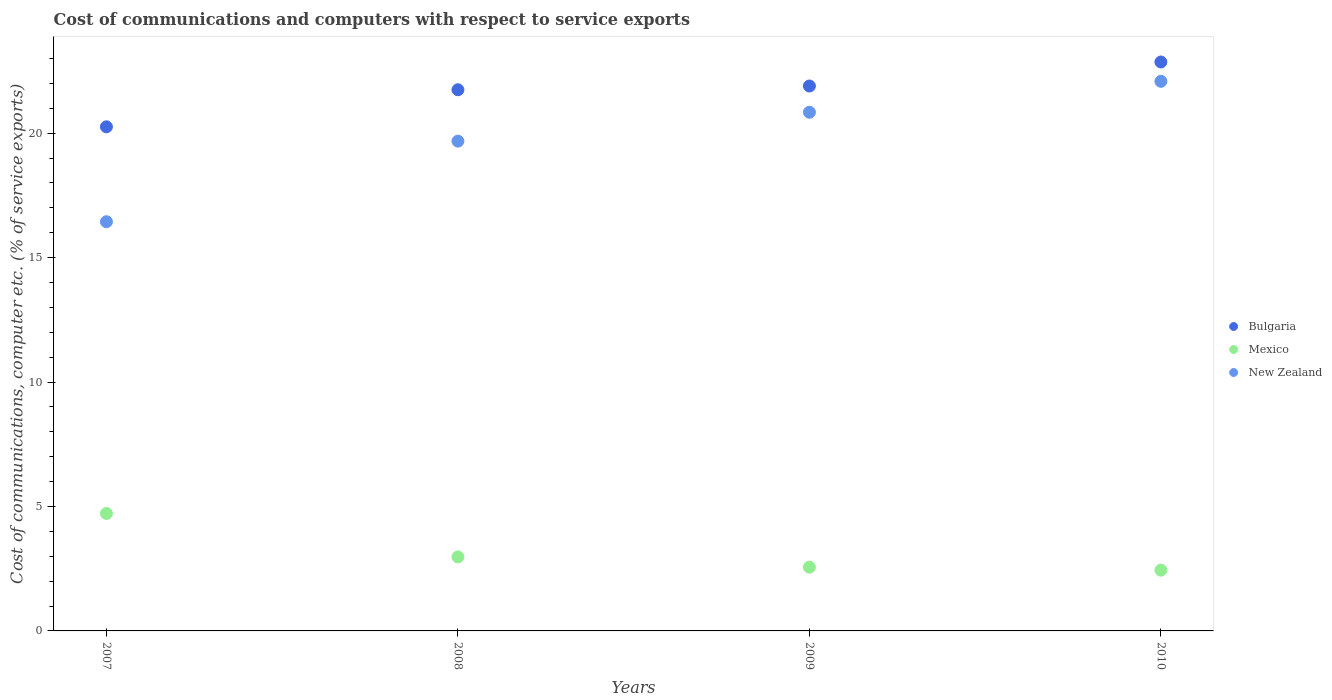How many different coloured dotlines are there?
Your answer should be compact. 3. What is the cost of communications and computers in Bulgaria in 2007?
Give a very brief answer. 20.25. Across all years, what is the maximum cost of communications and computers in Mexico?
Your answer should be compact. 4.72. Across all years, what is the minimum cost of communications and computers in Mexico?
Your answer should be very brief. 2.44. In which year was the cost of communications and computers in Bulgaria minimum?
Offer a terse response. 2007. What is the total cost of communications and computers in Bulgaria in the graph?
Your answer should be compact. 86.75. What is the difference between the cost of communications and computers in New Zealand in 2007 and that in 2009?
Your response must be concise. -4.4. What is the difference between the cost of communications and computers in Bulgaria in 2010 and the cost of communications and computers in New Zealand in 2007?
Provide a succinct answer. 6.42. What is the average cost of communications and computers in Mexico per year?
Offer a terse response. 3.17. In the year 2009, what is the difference between the cost of communications and computers in Bulgaria and cost of communications and computers in New Zealand?
Give a very brief answer. 1.05. What is the ratio of the cost of communications and computers in New Zealand in 2008 to that in 2009?
Provide a succinct answer. 0.94. What is the difference between the highest and the second highest cost of communications and computers in Bulgaria?
Offer a terse response. 0.97. What is the difference between the highest and the lowest cost of communications and computers in Mexico?
Your response must be concise. 2.28. In how many years, is the cost of communications and computers in Mexico greater than the average cost of communications and computers in Mexico taken over all years?
Offer a terse response. 1. Is the sum of the cost of communications and computers in New Zealand in 2009 and 2010 greater than the maximum cost of communications and computers in Bulgaria across all years?
Your answer should be very brief. Yes. Does the cost of communications and computers in New Zealand monotonically increase over the years?
Give a very brief answer. Yes. Is the cost of communications and computers in New Zealand strictly greater than the cost of communications and computers in Bulgaria over the years?
Provide a succinct answer. No. How many dotlines are there?
Your response must be concise. 3. What is the difference between two consecutive major ticks on the Y-axis?
Your response must be concise. 5. Are the values on the major ticks of Y-axis written in scientific E-notation?
Your response must be concise. No. Does the graph contain grids?
Give a very brief answer. No. What is the title of the graph?
Keep it short and to the point. Cost of communications and computers with respect to service exports. Does "Nepal" appear as one of the legend labels in the graph?
Keep it short and to the point. No. What is the label or title of the Y-axis?
Provide a succinct answer. Cost of communications, computer etc. (% of service exports). What is the Cost of communications, computer etc. (% of service exports) in Bulgaria in 2007?
Provide a short and direct response. 20.25. What is the Cost of communications, computer etc. (% of service exports) of Mexico in 2007?
Keep it short and to the point. 4.72. What is the Cost of communications, computer etc. (% of service exports) in New Zealand in 2007?
Offer a very short reply. 16.44. What is the Cost of communications, computer etc. (% of service exports) in Bulgaria in 2008?
Keep it short and to the point. 21.74. What is the Cost of communications, computer etc. (% of service exports) in Mexico in 2008?
Provide a short and direct response. 2.97. What is the Cost of communications, computer etc. (% of service exports) of New Zealand in 2008?
Ensure brevity in your answer.  19.68. What is the Cost of communications, computer etc. (% of service exports) of Bulgaria in 2009?
Keep it short and to the point. 21.89. What is the Cost of communications, computer etc. (% of service exports) in Mexico in 2009?
Provide a short and direct response. 2.56. What is the Cost of communications, computer etc. (% of service exports) of New Zealand in 2009?
Ensure brevity in your answer.  20.84. What is the Cost of communications, computer etc. (% of service exports) in Bulgaria in 2010?
Offer a terse response. 22.86. What is the Cost of communications, computer etc. (% of service exports) in Mexico in 2010?
Offer a very short reply. 2.44. What is the Cost of communications, computer etc. (% of service exports) of New Zealand in 2010?
Keep it short and to the point. 22.08. Across all years, what is the maximum Cost of communications, computer etc. (% of service exports) of Bulgaria?
Give a very brief answer. 22.86. Across all years, what is the maximum Cost of communications, computer etc. (% of service exports) in Mexico?
Your answer should be compact. 4.72. Across all years, what is the maximum Cost of communications, computer etc. (% of service exports) in New Zealand?
Offer a terse response. 22.08. Across all years, what is the minimum Cost of communications, computer etc. (% of service exports) of Bulgaria?
Make the answer very short. 20.25. Across all years, what is the minimum Cost of communications, computer etc. (% of service exports) of Mexico?
Offer a terse response. 2.44. Across all years, what is the minimum Cost of communications, computer etc. (% of service exports) in New Zealand?
Make the answer very short. 16.44. What is the total Cost of communications, computer etc. (% of service exports) of Bulgaria in the graph?
Your response must be concise. 86.75. What is the total Cost of communications, computer etc. (% of service exports) of Mexico in the graph?
Ensure brevity in your answer.  12.7. What is the total Cost of communications, computer etc. (% of service exports) in New Zealand in the graph?
Offer a very short reply. 79.04. What is the difference between the Cost of communications, computer etc. (% of service exports) in Bulgaria in 2007 and that in 2008?
Keep it short and to the point. -1.49. What is the difference between the Cost of communications, computer etc. (% of service exports) in Mexico in 2007 and that in 2008?
Ensure brevity in your answer.  1.75. What is the difference between the Cost of communications, computer etc. (% of service exports) in New Zealand in 2007 and that in 2008?
Your answer should be compact. -3.24. What is the difference between the Cost of communications, computer etc. (% of service exports) of Bulgaria in 2007 and that in 2009?
Your response must be concise. -1.64. What is the difference between the Cost of communications, computer etc. (% of service exports) in Mexico in 2007 and that in 2009?
Your response must be concise. 2.16. What is the difference between the Cost of communications, computer etc. (% of service exports) in New Zealand in 2007 and that in 2009?
Your response must be concise. -4.4. What is the difference between the Cost of communications, computer etc. (% of service exports) of Bulgaria in 2007 and that in 2010?
Your response must be concise. -2.6. What is the difference between the Cost of communications, computer etc. (% of service exports) in Mexico in 2007 and that in 2010?
Your response must be concise. 2.28. What is the difference between the Cost of communications, computer etc. (% of service exports) in New Zealand in 2007 and that in 2010?
Make the answer very short. -5.64. What is the difference between the Cost of communications, computer etc. (% of service exports) in Bulgaria in 2008 and that in 2009?
Ensure brevity in your answer.  -0.15. What is the difference between the Cost of communications, computer etc. (% of service exports) of Mexico in 2008 and that in 2009?
Give a very brief answer. 0.41. What is the difference between the Cost of communications, computer etc. (% of service exports) in New Zealand in 2008 and that in 2009?
Keep it short and to the point. -1.16. What is the difference between the Cost of communications, computer etc. (% of service exports) in Bulgaria in 2008 and that in 2010?
Provide a succinct answer. -1.12. What is the difference between the Cost of communications, computer etc. (% of service exports) of Mexico in 2008 and that in 2010?
Provide a succinct answer. 0.53. What is the difference between the Cost of communications, computer etc. (% of service exports) of New Zealand in 2008 and that in 2010?
Give a very brief answer. -2.4. What is the difference between the Cost of communications, computer etc. (% of service exports) of Bulgaria in 2009 and that in 2010?
Your answer should be very brief. -0.97. What is the difference between the Cost of communications, computer etc. (% of service exports) in Mexico in 2009 and that in 2010?
Keep it short and to the point. 0.12. What is the difference between the Cost of communications, computer etc. (% of service exports) in New Zealand in 2009 and that in 2010?
Your answer should be very brief. -1.24. What is the difference between the Cost of communications, computer etc. (% of service exports) of Bulgaria in 2007 and the Cost of communications, computer etc. (% of service exports) of Mexico in 2008?
Provide a short and direct response. 17.28. What is the difference between the Cost of communications, computer etc. (% of service exports) in Bulgaria in 2007 and the Cost of communications, computer etc. (% of service exports) in New Zealand in 2008?
Provide a succinct answer. 0.58. What is the difference between the Cost of communications, computer etc. (% of service exports) of Mexico in 2007 and the Cost of communications, computer etc. (% of service exports) of New Zealand in 2008?
Your answer should be compact. -14.96. What is the difference between the Cost of communications, computer etc. (% of service exports) of Bulgaria in 2007 and the Cost of communications, computer etc. (% of service exports) of Mexico in 2009?
Ensure brevity in your answer.  17.69. What is the difference between the Cost of communications, computer etc. (% of service exports) of Bulgaria in 2007 and the Cost of communications, computer etc. (% of service exports) of New Zealand in 2009?
Give a very brief answer. -0.59. What is the difference between the Cost of communications, computer etc. (% of service exports) of Mexico in 2007 and the Cost of communications, computer etc. (% of service exports) of New Zealand in 2009?
Provide a short and direct response. -16.12. What is the difference between the Cost of communications, computer etc. (% of service exports) of Bulgaria in 2007 and the Cost of communications, computer etc. (% of service exports) of Mexico in 2010?
Provide a succinct answer. 17.81. What is the difference between the Cost of communications, computer etc. (% of service exports) in Bulgaria in 2007 and the Cost of communications, computer etc. (% of service exports) in New Zealand in 2010?
Provide a short and direct response. -1.83. What is the difference between the Cost of communications, computer etc. (% of service exports) of Mexico in 2007 and the Cost of communications, computer etc. (% of service exports) of New Zealand in 2010?
Offer a terse response. -17.36. What is the difference between the Cost of communications, computer etc. (% of service exports) in Bulgaria in 2008 and the Cost of communications, computer etc. (% of service exports) in Mexico in 2009?
Your response must be concise. 19.18. What is the difference between the Cost of communications, computer etc. (% of service exports) in Bulgaria in 2008 and the Cost of communications, computer etc. (% of service exports) in New Zealand in 2009?
Provide a succinct answer. 0.9. What is the difference between the Cost of communications, computer etc. (% of service exports) in Mexico in 2008 and the Cost of communications, computer etc. (% of service exports) in New Zealand in 2009?
Ensure brevity in your answer.  -17.87. What is the difference between the Cost of communications, computer etc. (% of service exports) in Bulgaria in 2008 and the Cost of communications, computer etc. (% of service exports) in Mexico in 2010?
Your answer should be compact. 19.3. What is the difference between the Cost of communications, computer etc. (% of service exports) of Bulgaria in 2008 and the Cost of communications, computer etc. (% of service exports) of New Zealand in 2010?
Make the answer very short. -0.34. What is the difference between the Cost of communications, computer etc. (% of service exports) in Mexico in 2008 and the Cost of communications, computer etc. (% of service exports) in New Zealand in 2010?
Offer a very short reply. -19.11. What is the difference between the Cost of communications, computer etc. (% of service exports) of Bulgaria in 2009 and the Cost of communications, computer etc. (% of service exports) of Mexico in 2010?
Your answer should be compact. 19.45. What is the difference between the Cost of communications, computer etc. (% of service exports) in Bulgaria in 2009 and the Cost of communications, computer etc. (% of service exports) in New Zealand in 2010?
Give a very brief answer. -0.19. What is the difference between the Cost of communications, computer etc. (% of service exports) in Mexico in 2009 and the Cost of communications, computer etc. (% of service exports) in New Zealand in 2010?
Provide a short and direct response. -19.52. What is the average Cost of communications, computer etc. (% of service exports) in Bulgaria per year?
Your answer should be very brief. 21.69. What is the average Cost of communications, computer etc. (% of service exports) in Mexico per year?
Your answer should be compact. 3.17. What is the average Cost of communications, computer etc. (% of service exports) in New Zealand per year?
Your answer should be very brief. 19.76. In the year 2007, what is the difference between the Cost of communications, computer etc. (% of service exports) of Bulgaria and Cost of communications, computer etc. (% of service exports) of Mexico?
Ensure brevity in your answer.  15.54. In the year 2007, what is the difference between the Cost of communications, computer etc. (% of service exports) in Bulgaria and Cost of communications, computer etc. (% of service exports) in New Zealand?
Your answer should be very brief. 3.81. In the year 2007, what is the difference between the Cost of communications, computer etc. (% of service exports) of Mexico and Cost of communications, computer etc. (% of service exports) of New Zealand?
Make the answer very short. -11.72. In the year 2008, what is the difference between the Cost of communications, computer etc. (% of service exports) in Bulgaria and Cost of communications, computer etc. (% of service exports) in Mexico?
Ensure brevity in your answer.  18.77. In the year 2008, what is the difference between the Cost of communications, computer etc. (% of service exports) of Bulgaria and Cost of communications, computer etc. (% of service exports) of New Zealand?
Offer a terse response. 2.06. In the year 2008, what is the difference between the Cost of communications, computer etc. (% of service exports) of Mexico and Cost of communications, computer etc. (% of service exports) of New Zealand?
Offer a very short reply. -16.7. In the year 2009, what is the difference between the Cost of communications, computer etc. (% of service exports) in Bulgaria and Cost of communications, computer etc. (% of service exports) in Mexico?
Ensure brevity in your answer.  19.33. In the year 2009, what is the difference between the Cost of communications, computer etc. (% of service exports) in Bulgaria and Cost of communications, computer etc. (% of service exports) in New Zealand?
Ensure brevity in your answer.  1.05. In the year 2009, what is the difference between the Cost of communications, computer etc. (% of service exports) of Mexico and Cost of communications, computer etc. (% of service exports) of New Zealand?
Offer a very short reply. -18.28. In the year 2010, what is the difference between the Cost of communications, computer etc. (% of service exports) in Bulgaria and Cost of communications, computer etc. (% of service exports) in Mexico?
Your response must be concise. 20.42. In the year 2010, what is the difference between the Cost of communications, computer etc. (% of service exports) in Bulgaria and Cost of communications, computer etc. (% of service exports) in New Zealand?
Ensure brevity in your answer.  0.78. In the year 2010, what is the difference between the Cost of communications, computer etc. (% of service exports) of Mexico and Cost of communications, computer etc. (% of service exports) of New Zealand?
Ensure brevity in your answer.  -19.64. What is the ratio of the Cost of communications, computer etc. (% of service exports) of Bulgaria in 2007 to that in 2008?
Make the answer very short. 0.93. What is the ratio of the Cost of communications, computer etc. (% of service exports) of Mexico in 2007 to that in 2008?
Ensure brevity in your answer.  1.59. What is the ratio of the Cost of communications, computer etc. (% of service exports) of New Zealand in 2007 to that in 2008?
Make the answer very short. 0.84. What is the ratio of the Cost of communications, computer etc. (% of service exports) of Bulgaria in 2007 to that in 2009?
Your response must be concise. 0.93. What is the ratio of the Cost of communications, computer etc. (% of service exports) of Mexico in 2007 to that in 2009?
Your answer should be compact. 1.84. What is the ratio of the Cost of communications, computer etc. (% of service exports) in New Zealand in 2007 to that in 2009?
Offer a terse response. 0.79. What is the ratio of the Cost of communications, computer etc. (% of service exports) in Bulgaria in 2007 to that in 2010?
Provide a succinct answer. 0.89. What is the ratio of the Cost of communications, computer etc. (% of service exports) of Mexico in 2007 to that in 2010?
Ensure brevity in your answer.  1.93. What is the ratio of the Cost of communications, computer etc. (% of service exports) of New Zealand in 2007 to that in 2010?
Your answer should be compact. 0.74. What is the ratio of the Cost of communications, computer etc. (% of service exports) of Bulgaria in 2008 to that in 2009?
Make the answer very short. 0.99. What is the ratio of the Cost of communications, computer etc. (% of service exports) of Mexico in 2008 to that in 2009?
Your response must be concise. 1.16. What is the ratio of the Cost of communications, computer etc. (% of service exports) in New Zealand in 2008 to that in 2009?
Ensure brevity in your answer.  0.94. What is the ratio of the Cost of communications, computer etc. (% of service exports) in Bulgaria in 2008 to that in 2010?
Ensure brevity in your answer.  0.95. What is the ratio of the Cost of communications, computer etc. (% of service exports) of Mexico in 2008 to that in 2010?
Your answer should be very brief. 1.22. What is the ratio of the Cost of communications, computer etc. (% of service exports) of New Zealand in 2008 to that in 2010?
Provide a short and direct response. 0.89. What is the ratio of the Cost of communications, computer etc. (% of service exports) of Bulgaria in 2009 to that in 2010?
Your response must be concise. 0.96. What is the ratio of the Cost of communications, computer etc. (% of service exports) of Mexico in 2009 to that in 2010?
Your response must be concise. 1.05. What is the ratio of the Cost of communications, computer etc. (% of service exports) of New Zealand in 2009 to that in 2010?
Ensure brevity in your answer.  0.94. What is the difference between the highest and the second highest Cost of communications, computer etc. (% of service exports) of Bulgaria?
Keep it short and to the point. 0.97. What is the difference between the highest and the second highest Cost of communications, computer etc. (% of service exports) in Mexico?
Your response must be concise. 1.75. What is the difference between the highest and the second highest Cost of communications, computer etc. (% of service exports) of New Zealand?
Your answer should be compact. 1.24. What is the difference between the highest and the lowest Cost of communications, computer etc. (% of service exports) of Bulgaria?
Offer a terse response. 2.6. What is the difference between the highest and the lowest Cost of communications, computer etc. (% of service exports) of Mexico?
Offer a terse response. 2.28. What is the difference between the highest and the lowest Cost of communications, computer etc. (% of service exports) of New Zealand?
Provide a succinct answer. 5.64. 